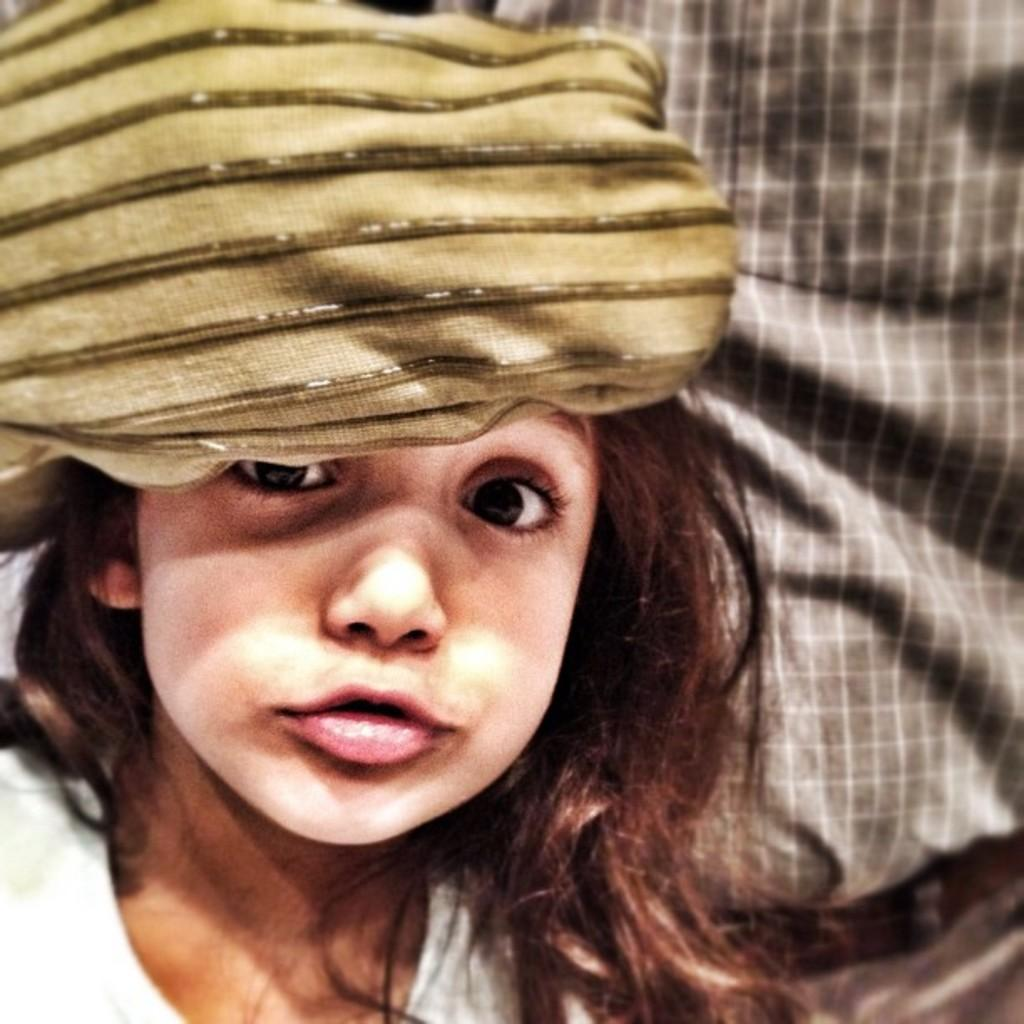Who is the main subject in the image? There is a girl in the image. What is the girl wearing? The girl is wearing a white dress and a green color head scarf. What is the girl doing in the image? The girl is looking at the camera. Can you describe the man in the background of the image? The man is wearing a grey shirt. How many hot insects can be seen flying around the girl in the image? There are no hot insects present in the image. 